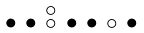<formula> <loc_0><loc_0><loc_500><loc_500>\begin{smallmatrix} & & \circ \\ \bullet & \bullet & \circ & \bullet & \bullet & \circ & \bullet & \\ \end{smallmatrix}</formula> 